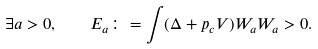<formula> <loc_0><loc_0><loc_500><loc_500>\exists a > 0 , \quad E _ { a } \colon = \int ( \Delta + p _ { c } V ) W _ { a } W _ { a } > 0 .</formula> 